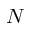<formula> <loc_0><loc_0><loc_500><loc_500>N</formula> 